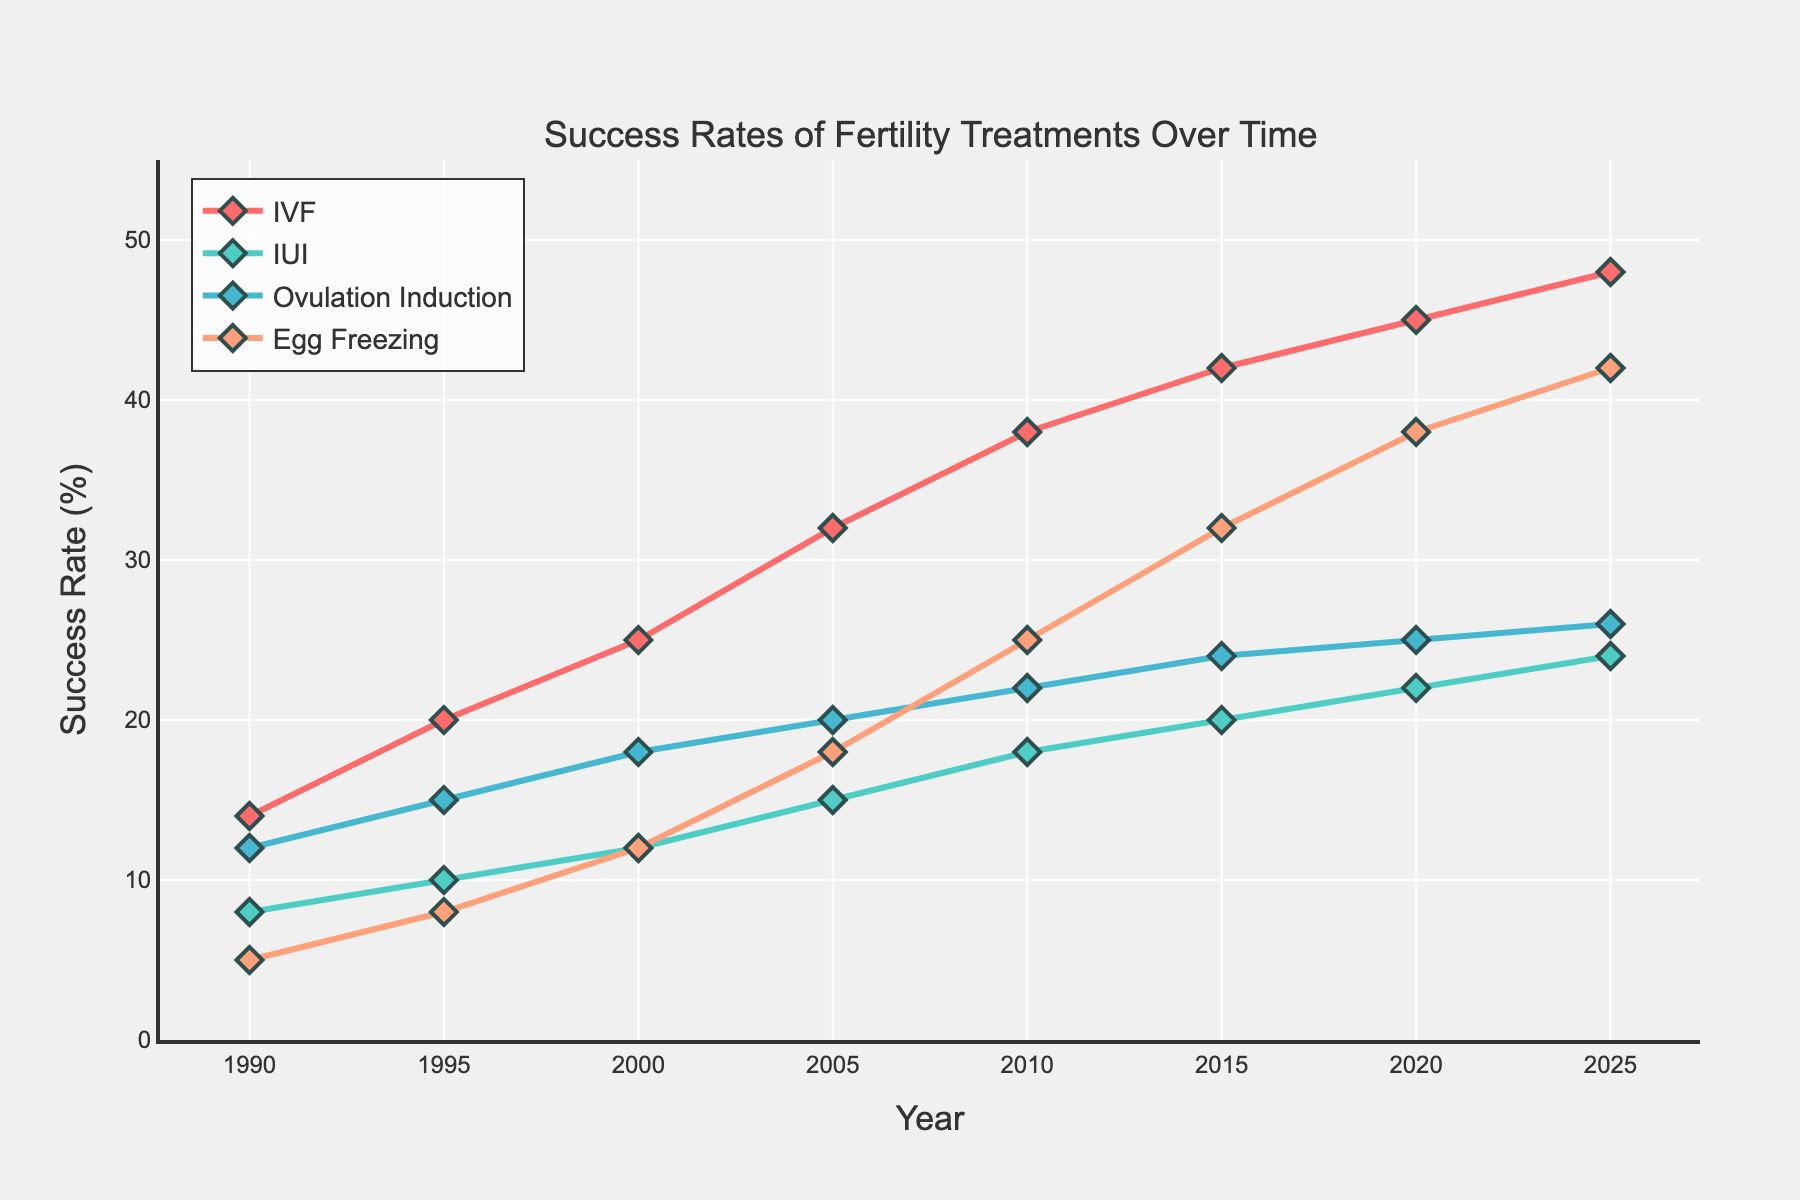Which fertility treatment has the highest success rate in 2025? Observing the values for 2025, Egg Freezing has a success rate of 42%, which is the highest among all treatments.
Answer: Egg Freezing Which treatment had the largest increase in success rate from 1990 to 2025? Subtract the 1990 values from the 2025 values for each treatment: IVF (48-14=34), IUI (24-8=16), Ovulation Induction (26-12=14), and Egg Freezing (42-5=37). Egg Freezing had the largest increase.
Answer: Egg Freezing Compare the success rates of IVF and IUI in 2010. Which one is higher and by how much? IVF’s success rate in 2010 is 38%, and IUI’s is 18%. The difference is 38 - 18 = 20%. IVF is higher by 20%.
Answer: IVF by 20% Which treatment has shown the most consistent growth over the years? By observing the smoothness and steady upward trend of the lines, IVF shows the most consistent growth with no large fluctuations over the years.
Answer: IVF What is the average success rate of Ovulation Induction over the entire period? Add the success rates of Ovulation Induction from 1990 to 2025 and divide by the number of data points: (12 + 15 + 18 + 20 + 22 + 24 + 25 + 26) / 8 = 20.25%.
Answer: 20.25% In what year did Egg Freezing first surpass a 20% success rate? Inspecting the trend line for Egg Freezing, it surpassed 20% in 2010 (with a success rate of 25%).
Answer: 2010 By how much did the success rate of IUI increase between 1995 and 2020? IUI’s success rate in 1995 was 10%, and in 2020 it was 22%. The increase is 22 - 10 = 12%.
Answer: 12% Which treatment had the least improvement in success rate between 2000 and 2020? By subtracting the success rates of each treatment from 2000 to 2020: IVF (45-25=20), IUI (22-12=10), Ovulation Induction (25-18=7), Egg Freezing (38-12=26). Ovulation Induction had the least improvement.
Answer: Ovulation Induction During which decade did IVF experience the most growth in success rate? Calculate the growth per decade: 1990s (20-14=6), 2000s (32-25=7), 2010s (42-38=4), 2020s part (48-45=3). The 2000s show the most growth with a 7% increase.
Answer: 2000s 